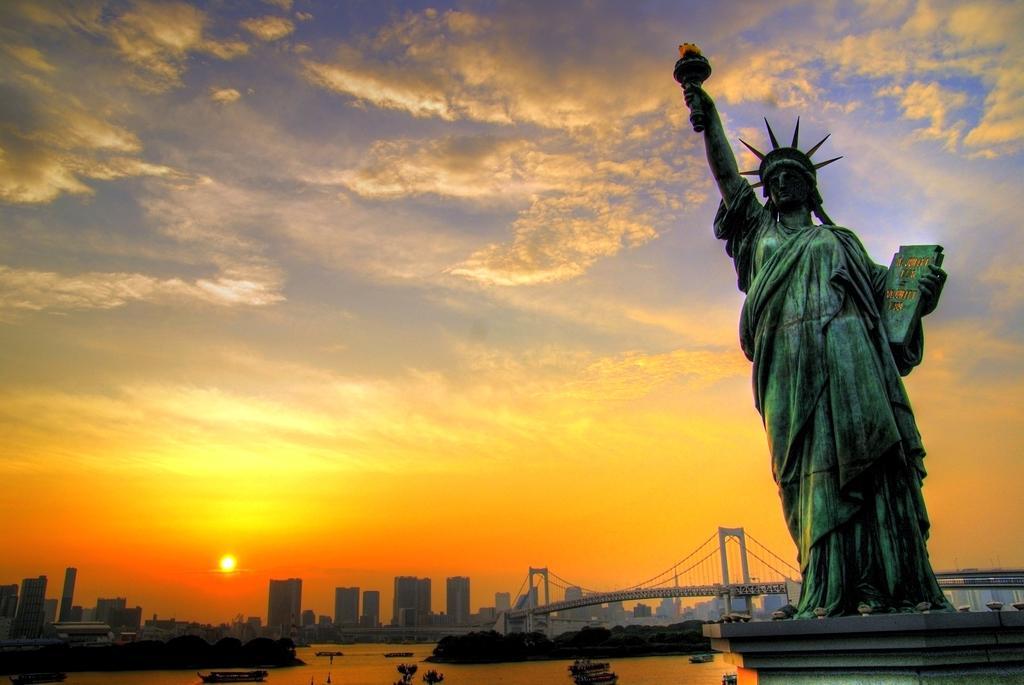How would you summarize this image in a sentence or two? In this image I can see a statue, background I can see water, trees, a bridge, few buildings and the sky is in yellow, orange, blue and white color and I can see the sun. 